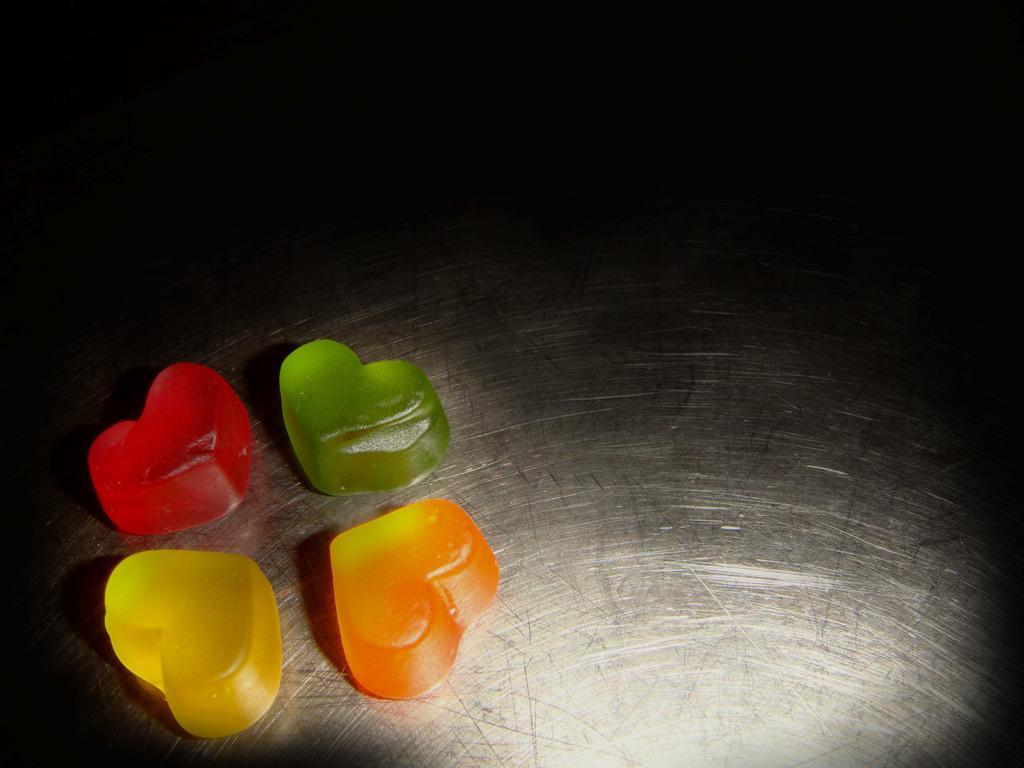In one or two sentences, can you explain what this image depicts? In this image I can see few jelly, they are in red, green, orange and yellow color on the black and white surface. 